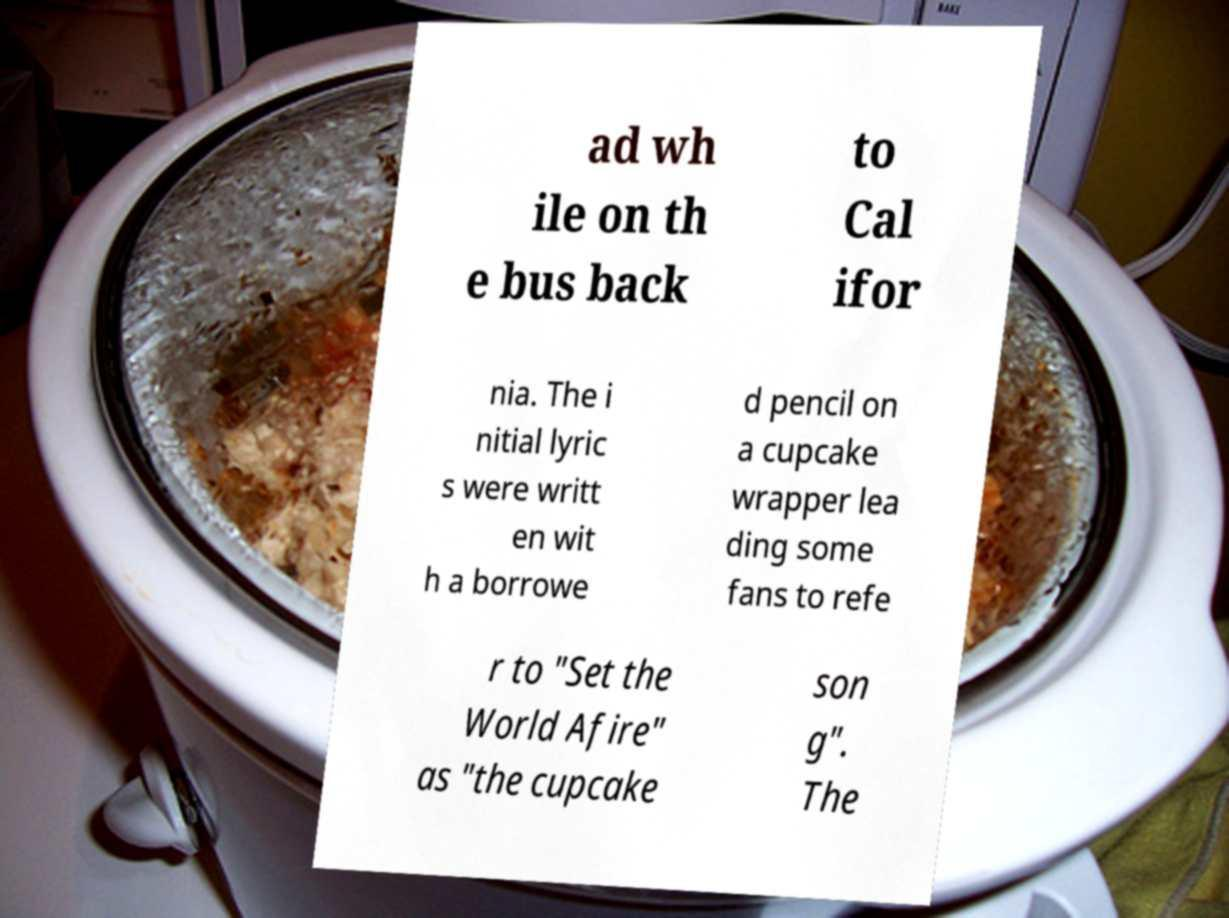I need the written content from this picture converted into text. Can you do that? ad wh ile on th e bus back to Cal ifor nia. The i nitial lyric s were writt en wit h a borrowe d pencil on a cupcake wrapper lea ding some fans to refe r to "Set the World Afire" as "the cupcake son g". The 